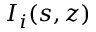<formula> <loc_0><loc_0><loc_500><loc_500>I _ { i } ( s , z )</formula> 